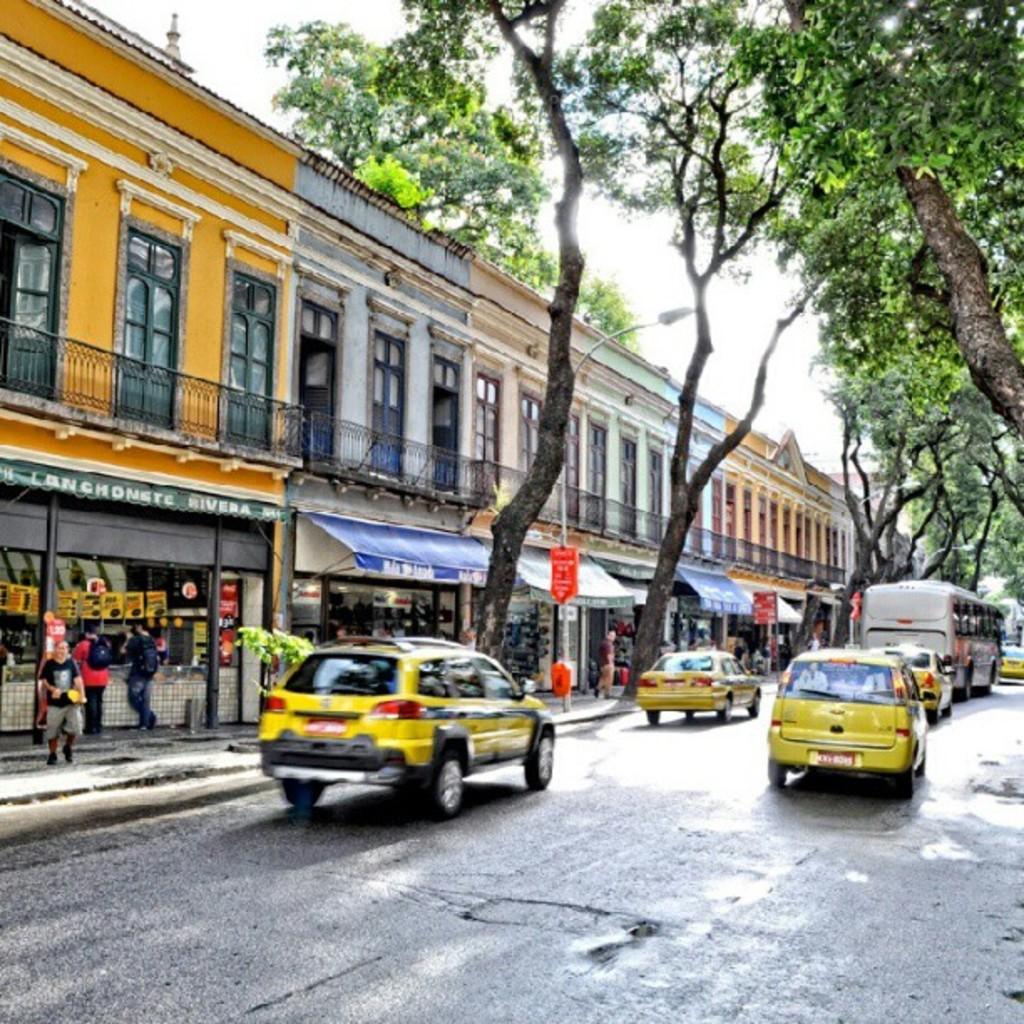What is the name of the store on the left?
Offer a terse response. Lanchonete rivera. 